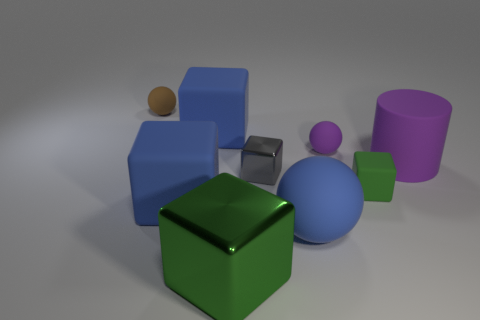How big is the matte object to the right of the block that is to the right of the small rubber sphere in front of the brown matte thing?
Ensure brevity in your answer.  Large. Is there a small thing that is in front of the rubber ball that is in front of the tiny ball in front of the brown thing?
Your answer should be very brief. No. Is the number of tiny purple matte objects greater than the number of large brown objects?
Ensure brevity in your answer.  Yes. The matte block behind the tiny shiny cube is what color?
Offer a very short reply. Blue. Are there more balls that are to the right of the small brown matte object than big green objects?
Offer a terse response. Yes. Are the small purple ball and the brown sphere made of the same material?
Ensure brevity in your answer.  Yes. What number of other objects are the same shape as the large metal object?
Keep it short and to the point. 4. Is there anything else that is the same material as the big ball?
Provide a short and direct response. Yes. The small ball in front of the small sphere that is left of the small matte ball that is in front of the small brown matte thing is what color?
Provide a short and direct response. Purple. Do the green object that is to the right of the big shiny cube and the small purple matte object have the same shape?
Ensure brevity in your answer.  No. 